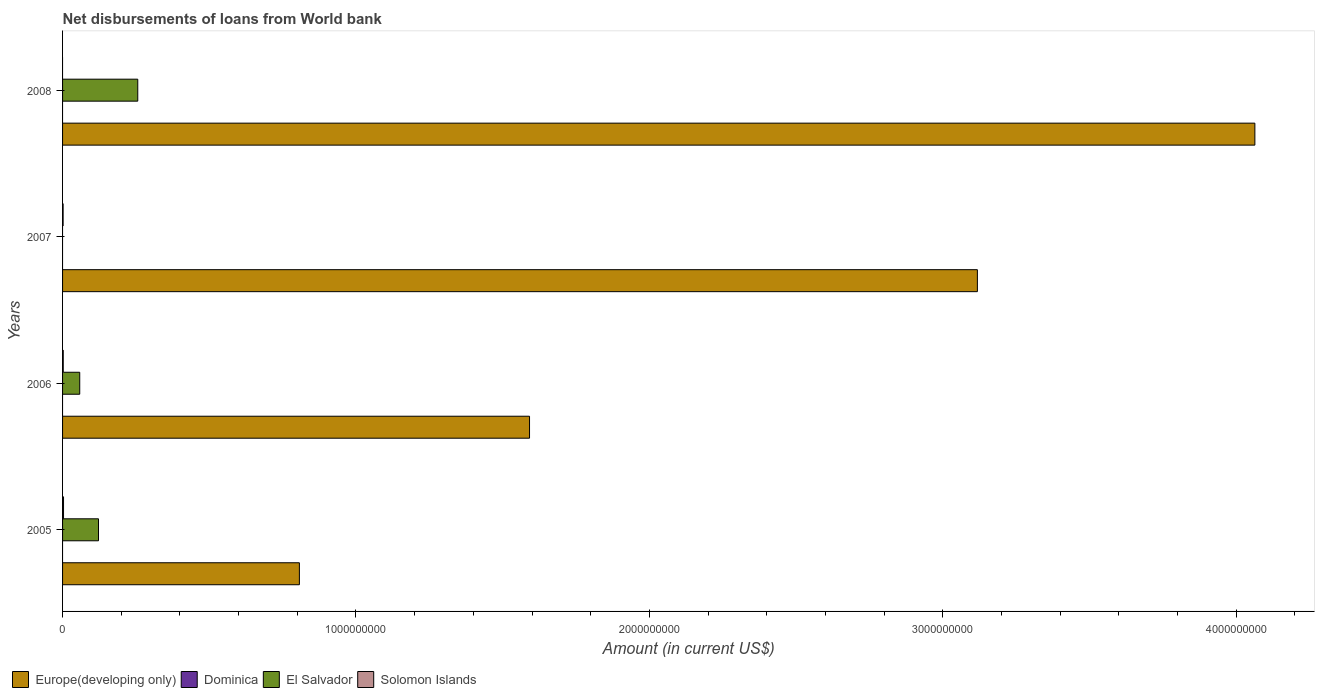Are the number of bars per tick equal to the number of legend labels?
Keep it short and to the point. No. How many bars are there on the 1st tick from the top?
Your response must be concise. 2. How many bars are there on the 2nd tick from the bottom?
Your response must be concise. 3. In how many cases, is the number of bars for a given year not equal to the number of legend labels?
Offer a very short reply. 4. Across all years, what is the maximum amount of loan disbursed from World Bank in Europe(developing only)?
Keep it short and to the point. 4.06e+09. Across all years, what is the minimum amount of loan disbursed from World Bank in El Salvador?
Offer a terse response. 0. What is the total amount of loan disbursed from World Bank in El Salvador in the graph?
Offer a terse response. 4.37e+08. What is the difference between the amount of loan disbursed from World Bank in Solomon Islands in 2006 and that in 2007?
Your answer should be very brief. 4.01e+05. What is the difference between the amount of loan disbursed from World Bank in Solomon Islands in 2006 and the amount of loan disbursed from World Bank in Europe(developing only) in 2007?
Your response must be concise. -3.12e+09. What is the average amount of loan disbursed from World Bank in El Salvador per year?
Offer a terse response. 1.09e+08. In the year 2005, what is the difference between the amount of loan disbursed from World Bank in Europe(developing only) and amount of loan disbursed from World Bank in Solomon Islands?
Offer a terse response. 8.04e+08. What is the ratio of the amount of loan disbursed from World Bank in El Salvador in 2005 to that in 2006?
Make the answer very short. 2.09. Is the difference between the amount of loan disbursed from World Bank in Europe(developing only) in 2006 and 2007 greater than the difference between the amount of loan disbursed from World Bank in Solomon Islands in 2006 and 2007?
Your response must be concise. No. What is the difference between the highest and the second highest amount of loan disbursed from World Bank in Solomon Islands?
Provide a succinct answer. 9.98e+05. What is the difference between the highest and the lowest amount of loan disbursed from World Bank in Europe(developing only)?
Your answer should be compact. 3.26e+09. In how many years, is the amount of loan disbursed from World Bank in Europe(developing only) greater than the average amount of loan disbursed from World Bank in Europe(developing only) taken over all years?
Make the answer very short. 2. Is the sum of the amount of loan disbursed from World Bank in Europe(developing only) in 2006 and 2007 greater than the maximum amount of loan disbursed from World Bank in El Salvador across all years?
Provide a short and direct response. Yes. Is it the case that in every year, the sum of the amount of loan disbursed from World Bank in Solomon Islands and amount of loan disbursed from World Bank in Europe(developing only) is greater than the sum of amount of loan disbursed from World Bank in El Salvador and amount of loan disbursed from World Bank in Dominica?
Keep it short and to the point. Yes. Is it the case that in every year, the sum of the amount of loan disbursed from World Bank in Europe(developing only) and amount of loan disbursed from World Bank in Dominica is greater than the amount of loan disbursed from World Bank in Solomon Islands?
Offer a very short reply. Yes. How many bars are there?
Your answer should be compact. 10. Are all the bars in the graph horizontal?
Provide a succinct answer. Yes. How many years are there in the graph?
Give a very brief answer. 4. What is the difference between two consecutive major ticks on the X-axis?
Your response must be concise. 1.00e+09. Are the values on the major ticks of X-axis written in scientific E-notation?
Offer a terse response. No. Does the graph contain any zero values?
Keep it short and to the point. Yes. Does the graph contain grids?
Offer a terse response. No. Where does the legend appear in the graph?
Provide a short and direct response. Bottom left. How many legend labels are there?
Provide a short and direct response. 4. What is the title of the graph?
Offer a very short reply. Net disbursements of loans from World bank. Does "Yemen, Rep." appear as one of the legend labels in the graph?
Your answer should be compact. No. What is the label or title of the X-axis?
Make the answer very short. Amount (in current US$). What is the label or title of the Y-axis?
Your answer should be very brief. Years. What is the Amount (in current US$) of Europe(developing only) in 2005?
Offer a terse response. 8.07e+08. What is the Amount (in current US$) in El Salvador in 2005?
Offer a terse response. 1.22e+08. What is the Amount (in current US$) in Solomon Islands in 2005?
Your answer should be very brief. 3.31e+06. What is the Amount (in current US$) in Europe(developing only) in 2006?
Provide a short and direct response. 1.59e+09. What is the Amount (in current US$) of El Salvador in 2006?
Make the answer very short. 5.85e+07. What is the Amount (in current US$) in Solomon Islands in 2006?
Your response must be concise. 2.31e+06. What is the Amount (in current US$) in Europe(developing only) in 2007?
Offer a very short reply. 3.12e+09. What is the Amount (in current US$) in Solomon Islands in 2007?
Keep it short and to the point. 1.91e+06. What is the Amount (in current US$) in Europe(developing only) in 2008?
Give a very brief answer. 4.06e+09. What is the Amount (in current US$) in Dominica in 2008?
Provide a short and direct response. 0. What is the Amount (in current US$) in El Salvador in 2008?
Keep it short and to the point. 2.56e+08. Across all years, what is the maximum Amount (in current US$) of Europe(developing only)?
Keep it short and to the point. 4.06e+09. Across all years, what is the maximum Amount (in current US$) of El Salvador?
Give a very brief answer. 2.56e+08. Across all years, what is the maximum Amount (in current US$) of Solomon Islands?
Give a very brief answer. 3.31e+06. Across all years, what is the minimum Amount (in current US$) in Europe(developing only)?
Make the answer very short. 8.07e+08. Across all years, what is the minimum Amount (in current US$) in El Salvador?
Provide a succinct answer. 0. Across all years, what is the minimum Amount (in current US$) in Solomon Islands?
Keep it short and to the point. 0. What is the total Amount (in current US$) of Europe(developing only) in the graph?
Offer a very short reply. 9.58e+09. What is the total Amount (in current US$) in Dominica in the graph?
Ensure brevity in your answer.  0. What is the total Amount (in current US$) in El Salvador in the graph?
Keep it short and to the point. 4.37e+08. What is the total Amount (in current US$) in Solomon Islands in the graph?
Give a very brief answer. 7.53e+06. What is the difference between the Amount (in current US$) of Europe(developing only) in 2005 and that in 2006?
Offer a very short reply. -7.84e+08. What is the difference between the Amount (in current US$) in El Salvador in 2005 and that in 2006?
Your answer should be very brief. 6.40e+07. What is the difference between the Amount (in current US$) in Solomon Islands in 2005 and that in 2006?
Your answer should be very brief. 9.98e+05. What is the difference between the Amount (in current US$) in Europe(developing only) in 2005 and that in 2007?
Your response must be concise. -2.31e+09. What is the difference between the Amount (in current US$) of Solomon Islands in 2005 and that in 2007?
Provide a succinct answer. 1.40e+06. What is the difference between the Amount (in current US$) in Europe(developing only) in 2005 and that in 2008?
Ensure brevity in your answer.  -3.26e+09. What is the difference between the Amount (in current US$) in El Salvador in 2005 and that in 2008?
Keep it short and to the point. -1.34e+08. What is the difference between the Amount (in current US$) in Europe(developing only) in 2006 and that in 2007?
Your response must be concise. -1.53e+09. What is the difference between the Amount (in current US$) of Solomon Islands in 2006 and that in 2007?
Ensure brevity in your answer.  4.01e+05. What is the difference between the Amount (in current US$) in Europe(developing only) in 2006 and that in 2008?
Provide a short and direct response. -2.47e+09. What is the difference between the Amount (in current US$) of El Salvador in 2006 and that in 2008?
Provide a short and direct response. -1.98e+08. What is the difference between the Amount (in current US$) in Europe(developing only) in 2007 and that in 2008?
Keep it short and to the point. -9.46e+08. What is the difference between the Amount (in current US$) in Europe(developing only) in 2005 and the Amount (in current US$) in El Salvador in 2006?
Give a very brief answer. 7.49e+08. What is the difference between the Amount (in current US$) in Europe(developing only) in 2005 and the Amount (in current US$) in Solomon Islands in 2006?
Your answer should be compact. 8.05e+08. What is the difference between the Amount (in current US$) of El Salvador in 2005 and the Amount (in current US$) of Solomon Islands in 2006?
Make the answer very short. 1.20e+08. What is the difference between the Amount (in current US$) of Europe(developing only) in 2005 and the Amount (in current US$) of Solomon Islands in 2007?
Your response must be concise. 8.05e+08. What is the difference between the Amount (in current US$) in El Salvador in 2005 and the Amount (in current US$) in Solomon Islands in 2007?
Provide a short and direct response. 1.21e+08. What is the difference between the Amount (in current US$) in Europe(developing only) in 2005 and the Amount (in current US$) in El Salvador in 2008?
Provide a succinct answer. 5.51e+08. What is the difference between the Amount (in current US$) of Europe(developing only) in 2006 and the Amount (in current US$) of Solomon Islands in 2007?
Your answer should be very brief. 1.59e+09. What is the difference between the Amount (in current US$) in El Salvador in 2006 and the Amount (in current US$) in Solomon Islands in 2007?
Make the answer very short. 5.66e+07. What is the difference between the Amount (in current US$) of Europe(developing only) in 2006 and the Amount (in current US$) of El Salvador in 2008?
Your answer should be very brief. 1.34e+09. What is the difference between the Amount (in current US$) of Europe(developing only) in 2007 and the Amount (in current US$) of El Salvador in 2008?
Offer a terse response. 2.86e+09. What is the average Amount (in current US$) of Europe(developing only) per year?
Offer a terse response. 2.40e+09. What is the average Amount (in current US$) in Dominica per year?
Offer a terse response. 0. What is the average Amount (in current US$) in El Salvador per year?
Keep it short and to the point. 1.09e+08. What is the average Amount (in current US$) of Solomon Islands per year?
Make the answer very short. 1.88e+06. In the year 2005, what is the difference between the Amount (in current US$) in Europe(developing only) and Amount (in current US$) in El Salvador?
Give a very brief answer. 6.85e+08. In the year 2005, what is the difference between the Amount (in current US$) in Europe(developing only) and Amount (in current US$) in Solomon Islands?
Your response must be concise. 8.04e+08. In the year 2005, what is the difference between the Amount (in current US$) in El Salvador and Amount (in current US$) in Solomon Islands?
Provide a short and direct response. 1.19e+08. In the year 2006, what is the difference between the Amount (in current US$) of Europe(developing only) and Amount (in current US$) of El Salvador?
Offer a terse response. 1.53e+09. In the year 2006, what is the difference between the Amount (in current US$) of Europe(developing only) and Amount (in current US$) of Solomon Islands?
Offer a terse response. 1.59e+09. In the year 2006, what is the difference between the Amount (in current US$) of El Salvador and Amount (in current US$) of Solomon Islands?
Give a very brief answer. 5.62e+07. In the year 2007, what is the difference between the Amount (in current US$) in Europe(developing only) and Amount (in current US$) in Solomon Islands?
Provide a succinct answer. 3.12e+09. In the year 2008, what is the difference between the Amount (in current US$) in Europe(developing only) and Amount (in current US$) in El Salvador?
Your response must be concise. 3.81e+09. What is the ratio of the Amount (in current US$) of Europe(developing only) in 2005 to that in 2006?
Give a very brief answer. 0.51. What is the ratio of the Amount (in current US$) in El Salvador in 2005 to that in 2006?
Provide a short and direct response. 2.09. What is the ratio of the Amount (in current US$) in Solomon Islands in 2005 to that in 2006?
Your response must be concise. 1.43. What is the ratio of the Amount (in current US$) in Europe(developing only) in 2005 to that in 2007?
Make the answer very short. 0.26. What is the ratio of the Amount (in current US$) of Solomon Islands in 2005 to that in 2007?
Offer a terse response. 1.73. What is the ratio of the Amount (in current US$) of Europe(developing only) in 2005 to that in 2008?
Make the answer very short. 0.2. What is the ratio of the Amount (in current US$) in El Salvador in 2005 to that in 2008?
Your answer should be compact. 0.48. What is the ratio of the Amount (in current US$) of Europe(developing only) in 2006 to that in 2007?
Offer a very short reply. 0.51. What is the ratio of the Amount (in current US$) of Solomon Islands in 2006 to that in 2007?
Keep it short and to the point. 1.21. What is the ratio of the Amount (in current US$) in Europe(developing only) in 2006 to that in 2008?
Ensure brevity in your answer.  0.39. What is the ratio of the Amount (in current US$) of El Salvador in 2006 to that in 2008?
Your response must be concise. 0.23. What is the ratio of the Amount (in current US$) in Europe(developing only) in 2007 to that in 2008?
Provide a short and direct response. 0.77. What is the difference between the highest and the second highest Amount (in current US$) of Europe(developing only)?
Make the answer very short. 9.46e+08. What is the difference between the highest and the second highest Amount (in current US$) of El Salvador?
Offer a terse response. 1.34e+08. What is the difference between the highest and the second highest Amount (in current US$) in Solomon Islands?
Provide a succinct answer. 9.98e+05. What is the difference between the highest and the lowest Amount (in current US$) in Europe(developing only)?
Your answer should be compact. 3.26e+09. What is the difference between the highest and the lowest Amount (in current US$) in El Salvador?
Offer a terse response. 2.56e+08. What is the difference between the highest and the lowest Amount (in current US$) in Solomon Islands?
Make the answer very short. 3.31e+06. 